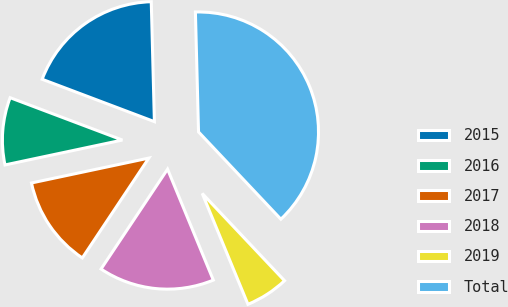Convert chart. <chart><loc_0><loc_0><loc_500><loc_500><pie_chart><fcel>2015<fcel>2016<fcel>2017<fcel>2018<fcel>2019<fcel>Total<nl><fcel>18.84%<fcel>9.07%<fcel>12.32%<fcel>15.58%<fcel>5.81%<fcel>38.38%<nl></chart> 